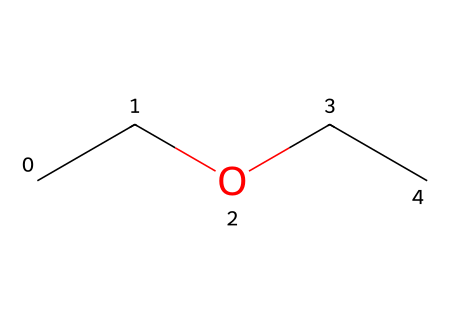How many carbon atoms are present in diethyl ether? The SMILES representation "CCOCC" indicates that there are two "C" characters at the beginning (CC) and two "C" characters at the end (CC), totaling four carbon atoms.
Answer: four What is the functional group present in diethyl ether? The presence of the oxygen atom (O) bonded between two ethyl groups gives it the characteristic ether functional group, which is denoted by the structure R-O-R, where R represents the alkyl groups.
Answer: ether How many hydrogen atoms are present in diethyl ether? Each carbon typically forms four bonds; with four carbon atoms present (from CC and CC), we can infer that for diethyl ether with its ether bond, there are two hydrogens directly attached to each of the terminal carbon atoms and one hydrogen for the central bond, resulting in a total of ten hydrogen atoms.
Answer: ten What type of chemical bond connects the carbon atoms in diethyl ether? The carbon atoms in the molecule are connected by single covalent bonds, which is indicated by the linear representation in the SMILES without any symbols for double or triple bonds, and the standard bonding configuration of carbon.
Answer: single Which part of the molecule indicates it is an ether? The structure shows that there is an oxygen atom (O) bonding two ethyl groups (CC), which is the key feature that defines ethers as they consist of an oxygen atom connected to two alkyl or aryl groups.
Answer: oxygen atom What is the molecular formula for diethyl ether? Counting the atoms represented in the SMILES "CCOCC", we arrive at four carbons (C4), ten hydrogens (H10), and one oxygen (O), together these components create the molecular formula C4H10O.
Answer: C4H10O Which two groups are alkyl groups in diethyl ether? The two ethyl groups (represented by "CC" at either end of the structure) are considered alkyl groups as they comprise carbon chains attached to the oxygen atom.
Answer: ethyl groups 